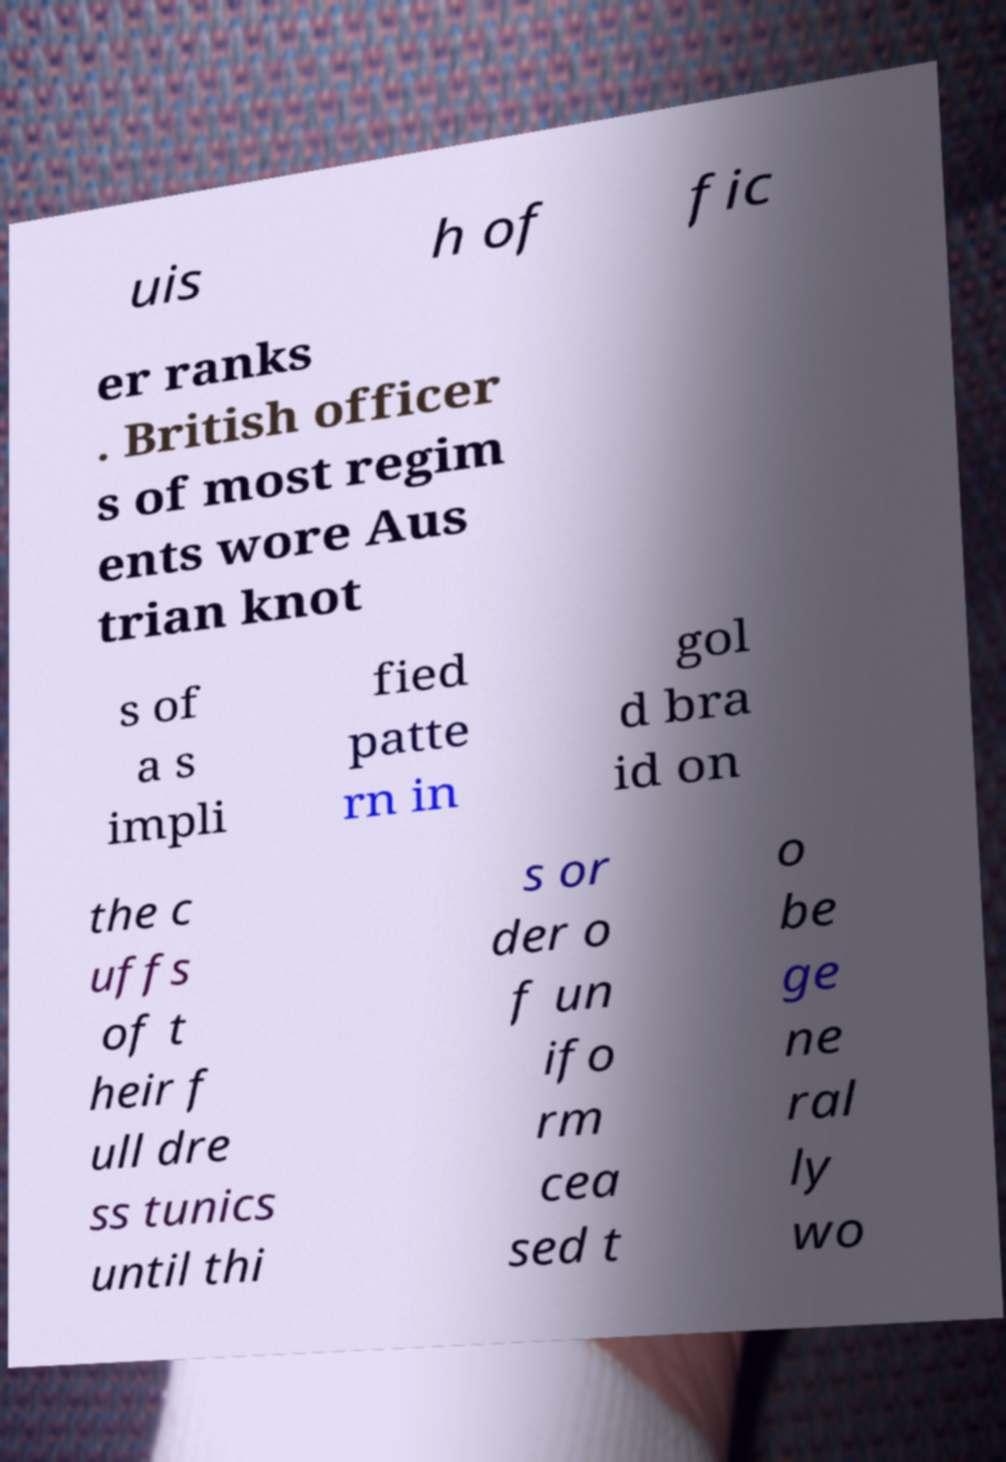Please read and relay the text visible in this image. What does it say? uis h of fic er ranks . British officer s of most regim ents wore Aus trian knot s of a s impli fied patte rn in gol d bra id on the c uffs of t heir f ull dre ss tunics until thi s or der o f un ifo rm cea sed t o be ge ne ral ly wo 